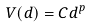<formula> <loc_0><loc_0><loc_500><loc_500>V ( d ) = C d ^ { p }</formula> 